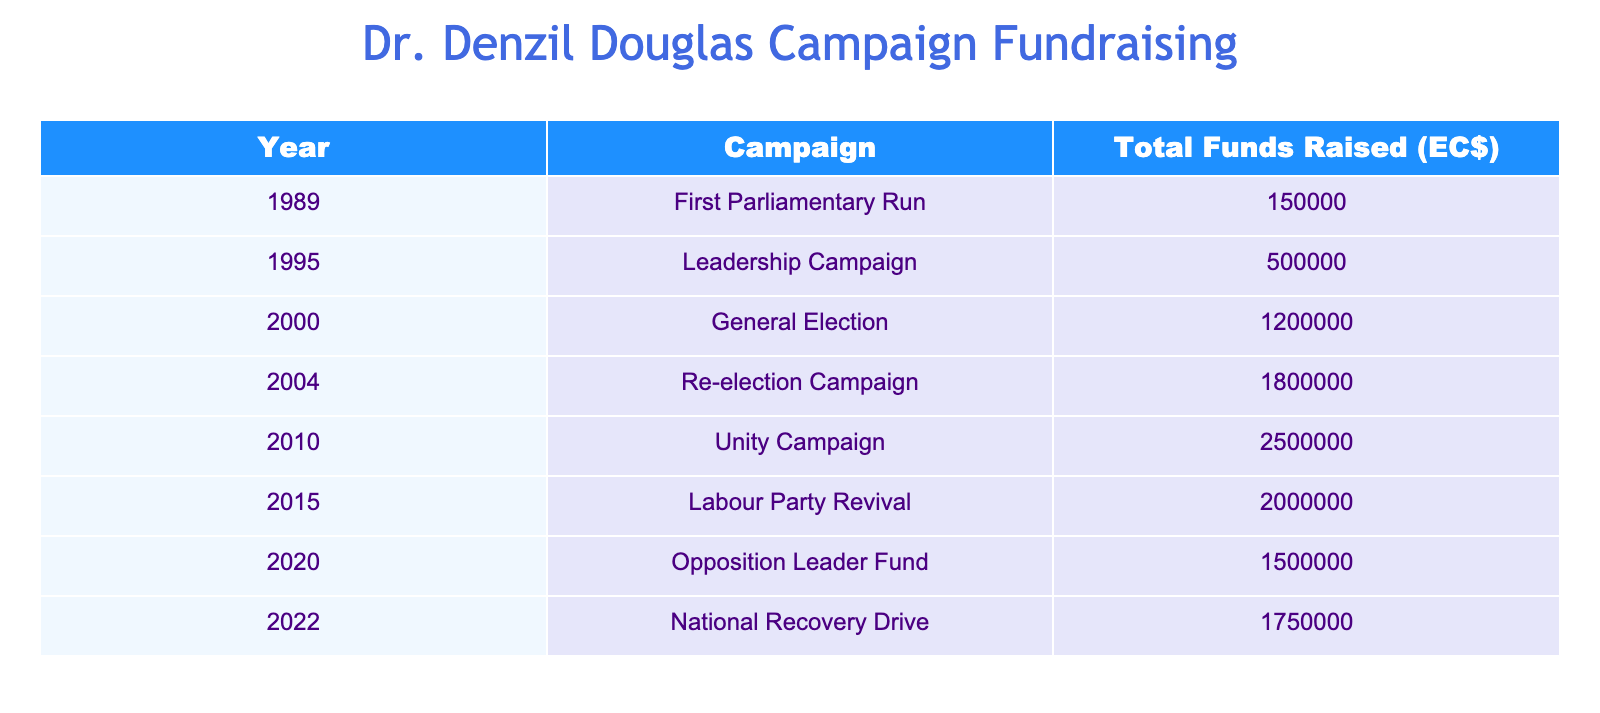What was the total amount raised in the 2004 Re-election Campaign? The table shows that the total funds raised for the 2004 Re-election Campaign is EC$ 1,800,000.
Answer: EC$ 1,800,000 Which campaign had the highest total funds raised? According to the table, the campaign with the highest total funds raised is the 2010 Unity Campaign, which raised EC$ 2,500,000.
Answer: 2010 Unity Campaign What is the total funds raised from the campaigns listed in the years 1995 to 2020? To find the total funds raised from the years 1995 to 2020, we add the amounts: EC$ 500,000 (1995) + EC$ 1,200,000 (2000) + EC$ 1,800,000 (2004) + EC$ 2,500,000 (2010) + EC$ 2,000,000 (2015) + EC$ 1,500,000 (2020) = EC$ 9,500,000.
Answer: EC$ 9,500,000 Did Dr. Denzil Douglas raise more funds in 2015 than in 2022? The table indicates that in 2015, Dr. Denzil Douglas raised EC$ 2,000,000, while in 2022, he raised EC$ 1,750,000. Since EC$ 2,000,000 is greater than EC$ 1,750,000, the answer is yes.
Answer: Yes What was the average amount raised per campaign over all years listed? To find the average, sum all the funds raised: EC$ 150,000 (1989) + EC$ 500,000 (1995) + EC$ 1,200,000 (2000) + EC$ 1,800,000 (2004) + EC$ 2,500,000 (2010) + EC$ 2,000,000 (2015) + EC$ 1,500,000 (2020) + EC$ 1,750,000 (2022) = EC$ 11,400,000. There are 8 campaigns, so the average is EC$ 11,400,000 / 8 = EC$ 1,425,000.
Answer: EC$ 1,425,000 